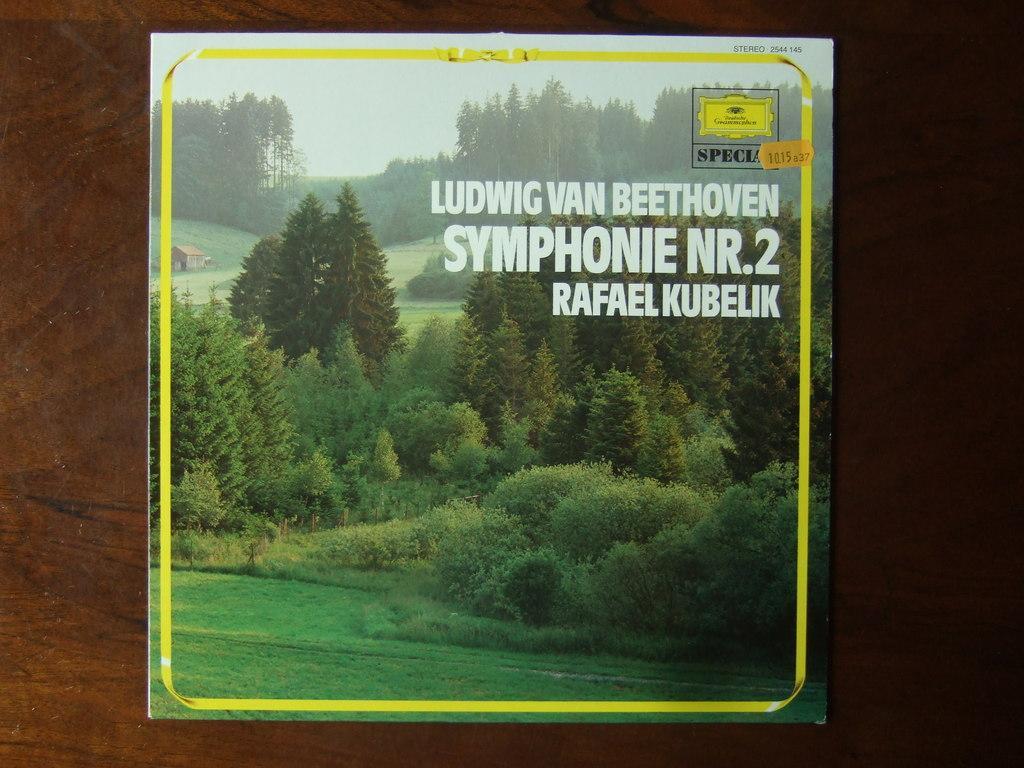Can you describe this image briefly? In this picture, we see an image of trees. At the bottom of the image, we see grass. There are trees in the background. On the left side of the image, we see a hut. In the background, it is brown in color. 